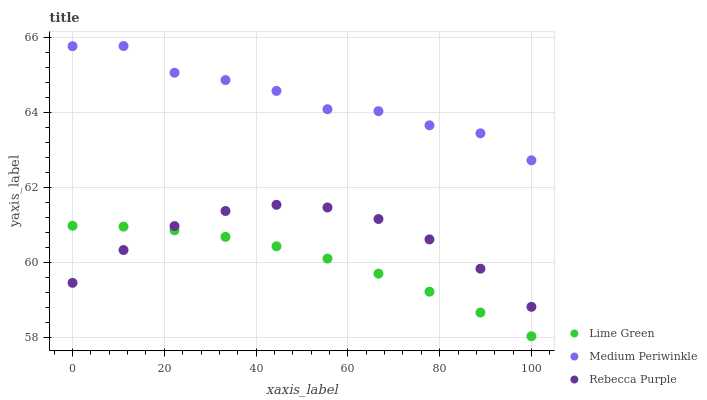Does Lime Green have the minimum area under the curve?
Answer yes or no. Yes. Does Medium Periwinkle have the maximum area under the curve?
Answer yes or no. Yes. Does Rebecca Purple have the minimum area under the curve?
Answer yes or no. No. Does Rebecca Purple have the maximum area under the curve?
Answer yes or no. No. Is Lime Green the smoothest?
Answer yes or no. Yes. Is Medium Periwinkle the roughest?
Answer yes or no. Yes. Is Rebecca Purple the smoothest?
Answer yes or no. No. Is Rebecca Purple the roughest?
Answer yes or no. No. Does Lime Green have the lowest value?
Answer yes or no. Yes. Does Rebecca Purple have the lowest value?
Answer yes or no. No. Does Medium Periwinkle have the highest value?
Answer yes or no. Yes. Does Rebecca Purple have the highest value?
Answer yes or no. No. Is Lime Green less than Medium Periwinkle?
Answer yes or no. Yes. Is Medium Periwinkle greater than Lime Green?
Answer yes or no. Yes. Does Lime Green intersect Rebecca Purple?
Answer yes or no. Yes. Is Lime Green less than Rebecca Purple?
Answer yes or no. No. Is Lime Green greater than Rebecca Purple?
Answer yes or no. No. Does Lime Green intersect Medium Periwinkle?
Answer yes or no. No. 